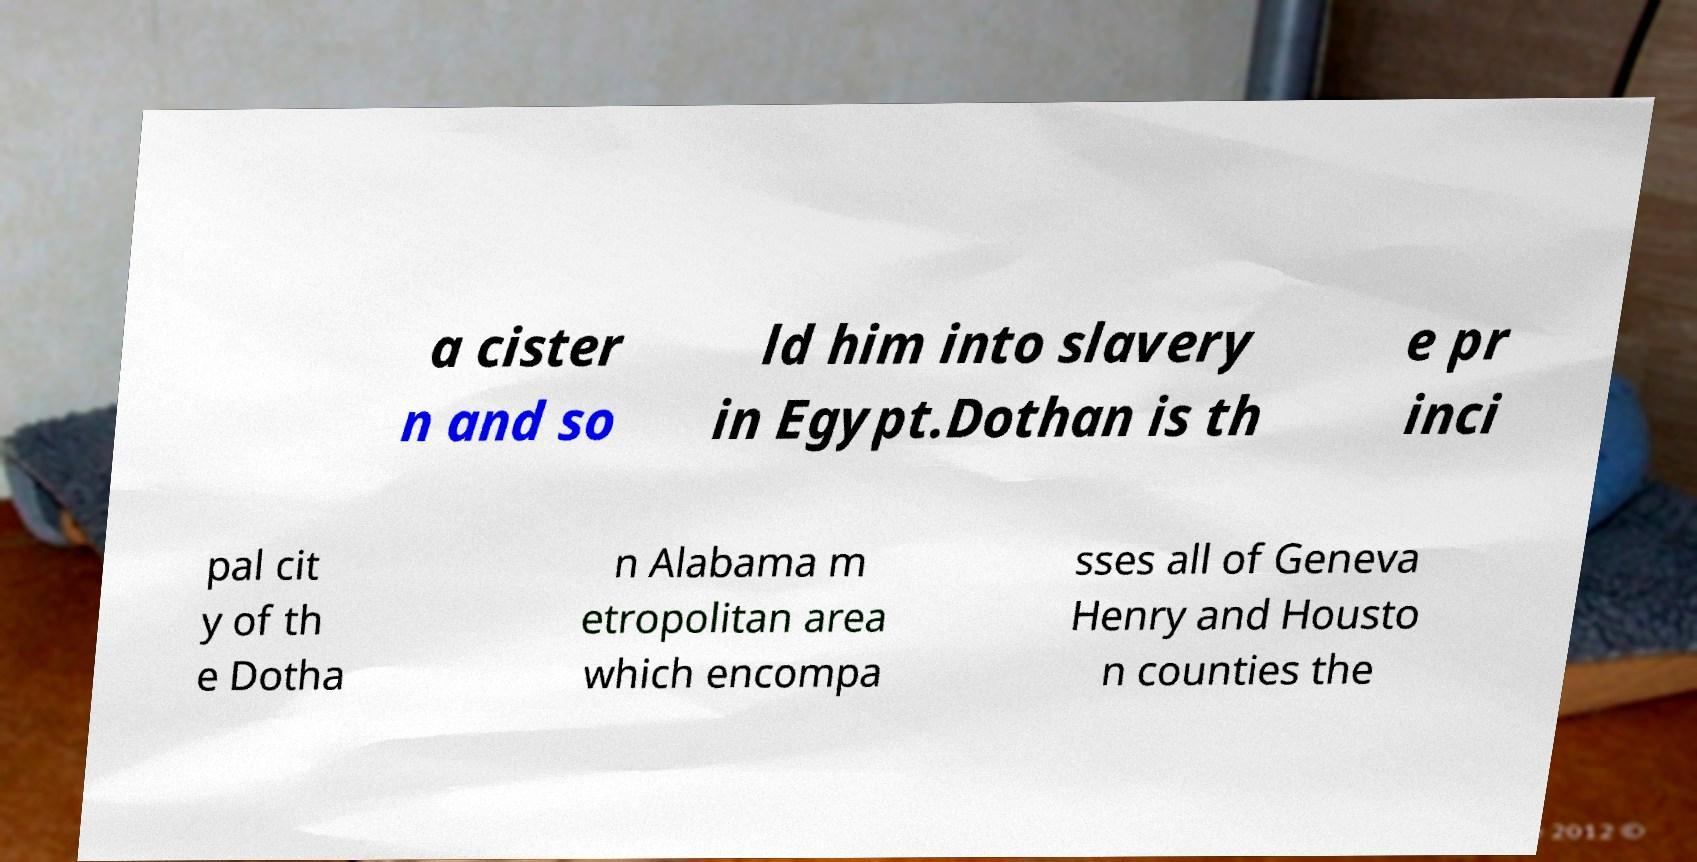Could you assist in decoding the text presented in this image and type it out clearly? a cister n and so ld him into slavery in Egypt.Dothan is th e pr inci pal cit y of th e Dotha n Alabama m etropolitan area which encompa sses all of Geneva Henry and Housto n counties the 